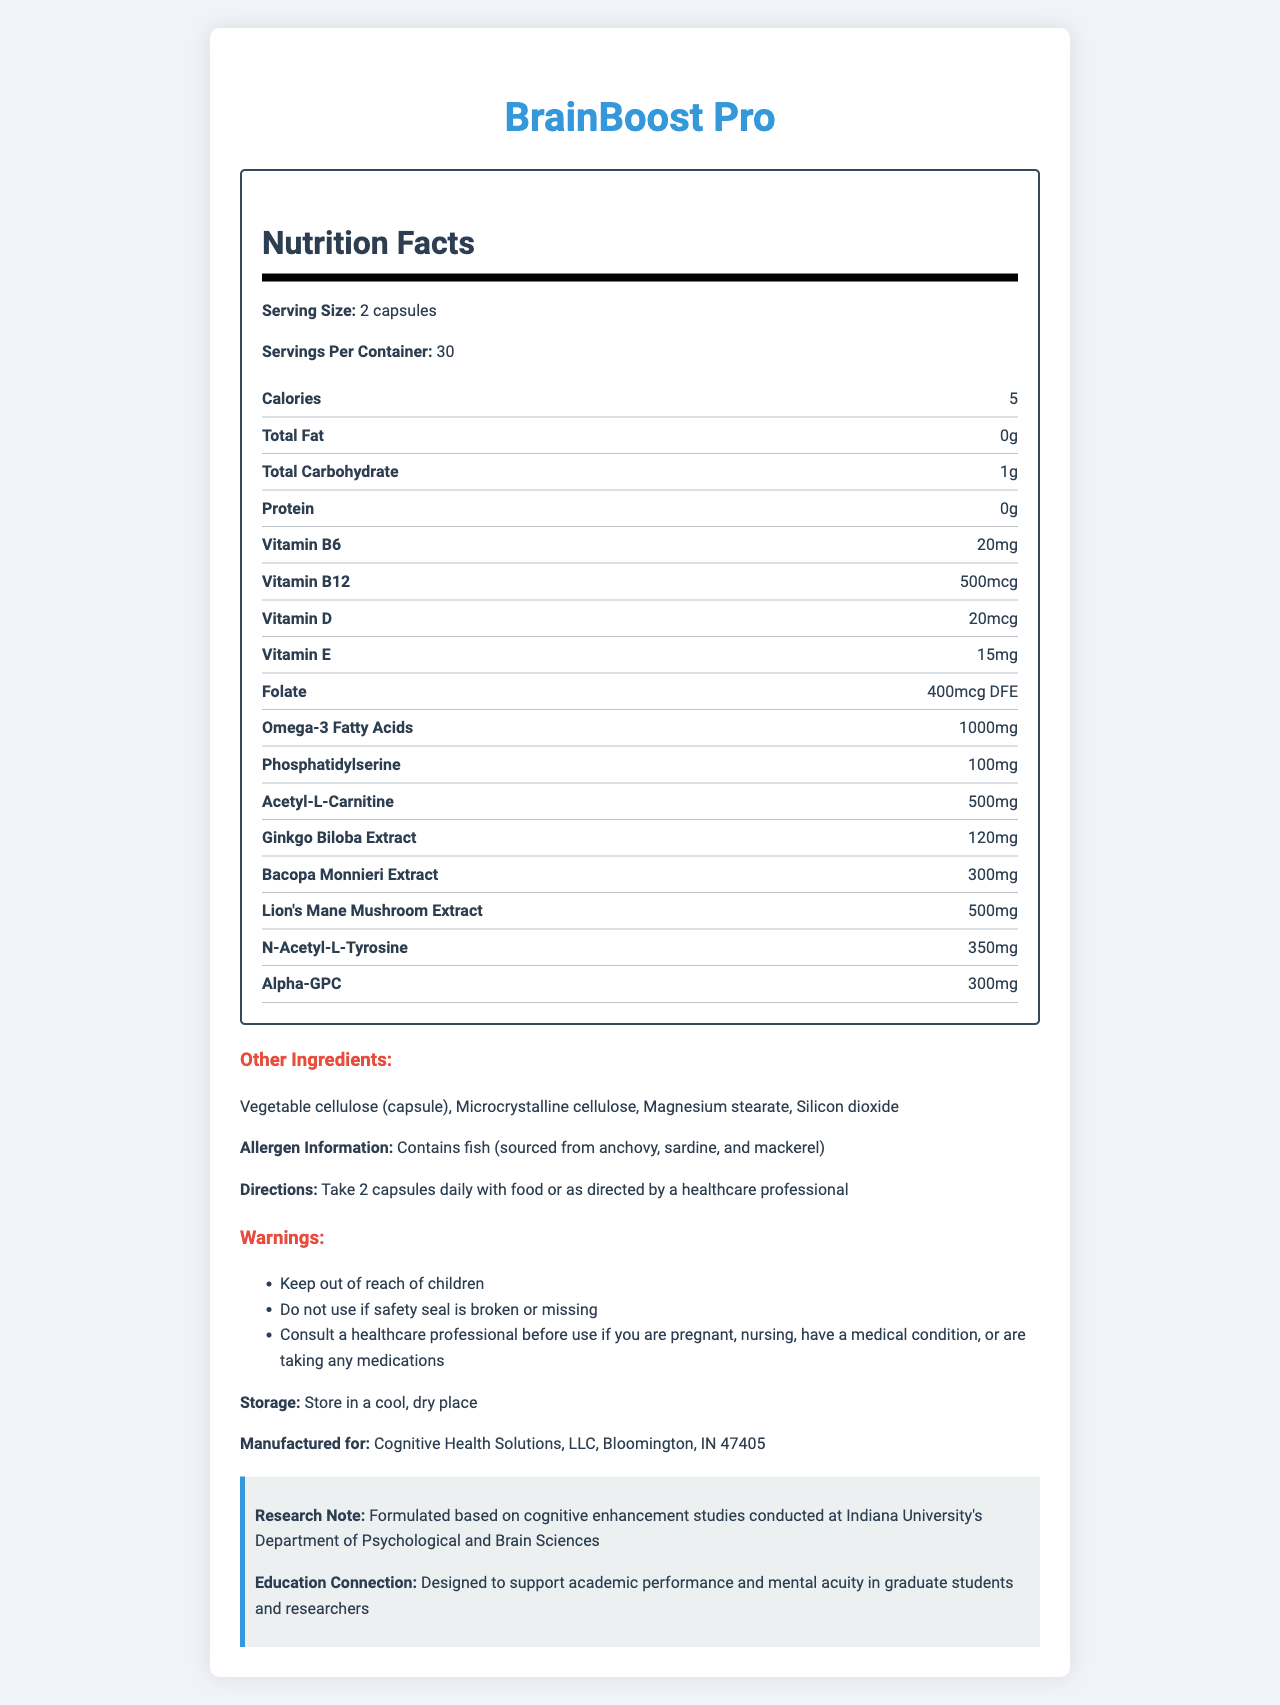what is the serving size for BrainBoost Pro? The document specifies the serving size as 2 capsules.
Answer: 2 capsules how many servings are there in one container of BrainBoost Pro? It states that there are 30 servings per container.
Answer: 30 how many calories are in each serving of BrainBoost Pro? The nutrition facts show that there are 5 calories per serving.
Answer: 5 calories what is the amount of Omega-3 fatty acids in one serving? The label indicates that one serving contains 1000mg of Omega-3 fatty acids.
Answer: 1000mg what is the source of allergens in BrainBoost Pro? The allergen information section states that the product contains fish sourced from anchovy, sardine, and mackerel.
Answer: Fish (sourced from anchovy, sardine, and mackerel) which vitamin has the highest quantity per serving in BrainBoost Pro? A. Vitamin B6 B. Vitamin B12 C. Vitamin D D. Vitamin E The document shows Vitamin B12 at 500mcg, which is the highest among the listed vitamins per serving.
Answer: B. Vitamin B12 what does the supplement help to support? A. Weight loss B. Digestive health C. Cognitive function and memory D. Cardiovascular health The product name "BrainBoost Pro" and several ingredients suggest cognitive function and memory support.
Answer: C. Cognitive function and memory is BrainBoost Pro safe for children? One of the warnings states to "Keep out of reach of children."
Answer: No how should BrainBoost Pro be stored? The document provides specific storage instructions stating "Store in a cool, dry place."
Answer: In a cool, dry place who manufactures BrainBoost Pro? The manufactured for section specifies this information.
Answer: Cognitive Health Solutions, LLC, Bloomington, IN 47405 describe the main idea of the BrainBoost Pro document. The document is a comprehensive nutrition label and information guide for BrainBoost Pro, including its benefits for cognitive function and memory, along with all necessary usage and safety details.
Answer: The document provides detailed information about BrainBoost Pro, a vitamin supplement designed to support cognitive function and memory. It includes nutrition facts, serving size and servings per container, ingredients, allergen information, usage directions, warnings, and storage instructions. The supplement is rich in vitamins, Omega-3 fatty acids, and other substances associated with cognitive benefits. what is the reason for consulting a healthcare professional before using BrainBoost Pro if you are pregnant, nursing, have a medical condition, or are taking medications? The warnings section advises consulting a healthcare professional before use if you are pregnant, nursing, have a medical condition, or are taking any medications.
Answer: The document warns to consult a healthcare professional under these conditions. what are “Other Ingredients” included in BrainBoost Pro capsules? The other ingredients section lists these substances.
Answer: Vegetable cellulose (capsule), Microcrystalline cellulose, Magnesium stearate, Silicon dioxide what is the connection between BrainBoost Pro and Indiana University? The research note in the document mentions this connection.
Answer: The formula is based on cognitive enhancement studies conducted at Indiana University’s Department of Psychological and Brain Sciences. what is Phosphatidylserine used for in BrainBoost Pro? The document lists the ingredient but does not specify its particular use.
Answer: Cannot be determined 